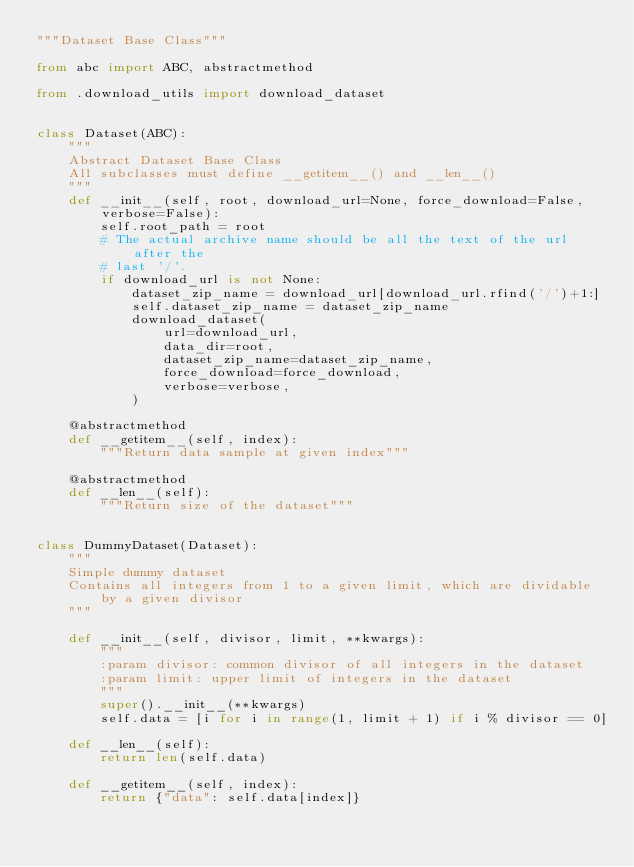<code> <loc_0><loc_0><loc_500><loc_500><_Python_>"""Dataset Base Class"""

from abc import ABC, abstractmethod

from .download_utils import download_dataset


class Dataset(ABC):
    """
    Abstract Dataset Base Class
    All subclasses must define __getitem__() and __len__()
    """
    def __init__(self, root, download_url=None, force_download=False, verbose=False):
        self.root_path = root
        # The actual archive name should be all the text of the url after the
        # last '/'.
        if download_url is not None:
            dataset_zip_name = download_url[download_url.rfind('/')+1:]
            self.dataset_zip_name = dataset_zip_name
            download_dataset(
                url=download_url,
                data_dir=root,
                dataset_zip_name=dataset_zip_name,
                force_download=force_download,
                verbose=verbose,
            )

    @abstractmethod
    def __getitem__(self, index):
        """Return data sample at given index"""

    @abstractmethod
    def __len__(self):
        """Return size of the dataset"""


class DummyDataset(Dataset):
    """
    Simple dummy dataset
    Contains all integers from 1 to a given limit, which are dividable by a given divisor
    """

    def __init__(self, divisor, limit, **kwargs):
        """
        :param divisor: common divisor of all integers in the dataset
        :param limit: upper limit of integers in the dataset
        """
        super().__init__(**kwargs)
        self.data = [i for i in range(1, limit + 1) if i % divisor == 0]

    def __len__(self):
        return len(self.data)

    def __getitem__(self, index):
        return {"data": self.data[index]}
</code> 